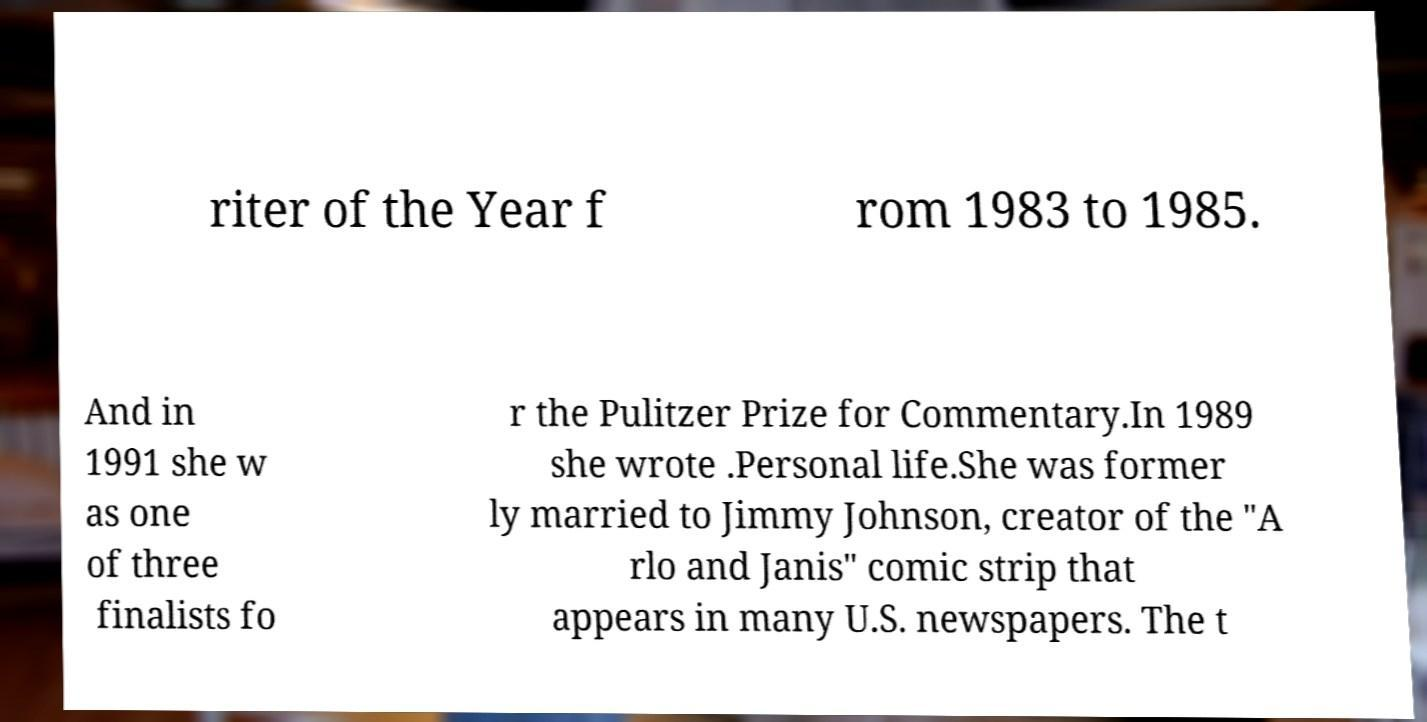What messages or text are displayed in this image? I need them in a readable, typed format. riter of the Year f rom 1983 to 1985. And in 1991 she w as one of three finalists fo r the Pulitzer Prize for Commentary.In 1989 she wrote .Personal life.She was former ly married to Jimmy Johnson, creator of the "A rlo and Janis" comic strip that appears in many U.S. newspapers. The t 